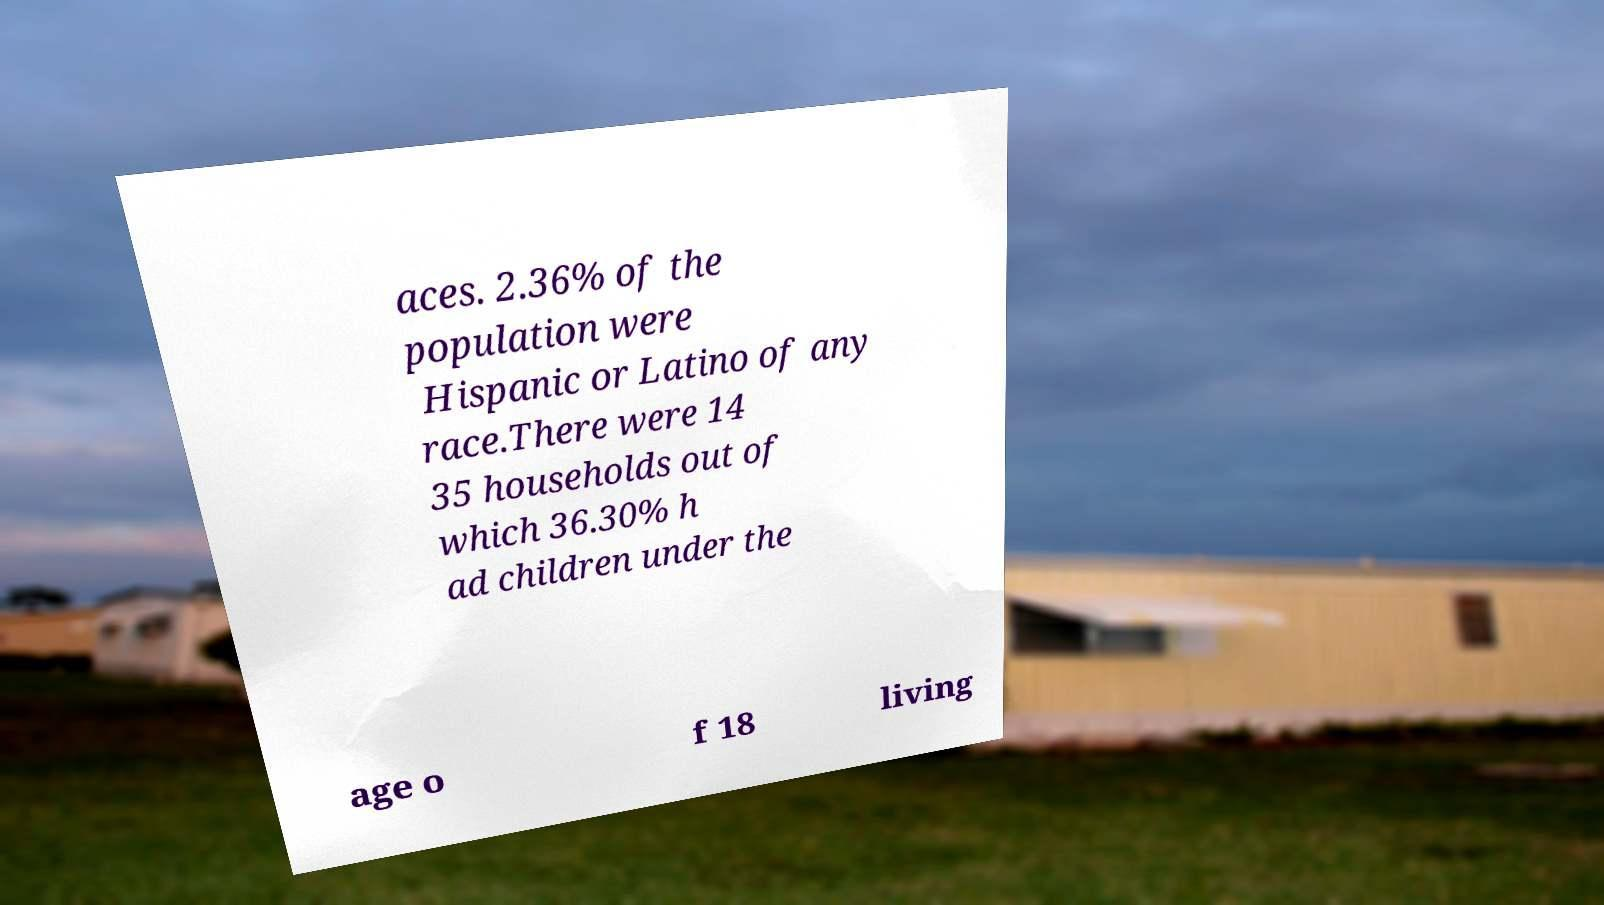Can you read and provide the text displayed in the image?This photo seems to have some interesting text. Can you extract and type it out for me? aces. 2.36% of the population were Hispanic or Latino of any race.There were 14 35 households out of which 36.30% h ad children under the age o f 18 living 